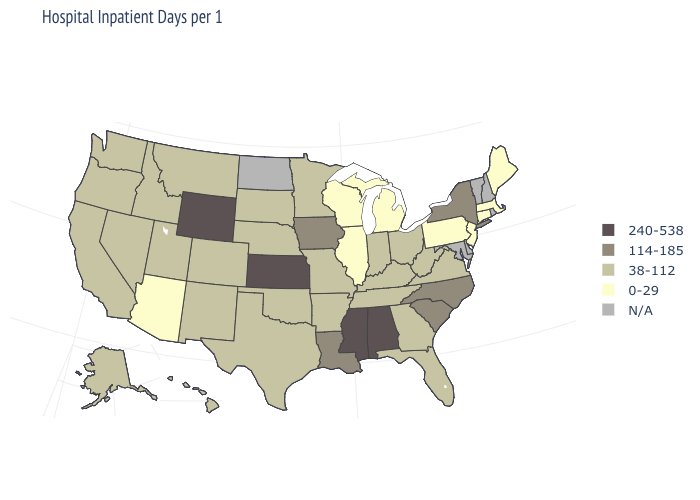What is the value of New Mexico?
Be succinct. 38-112. Name the states that have a value in the range N/A?
Answer briefly. Delaware, Maryland, New Hampshire, North Dakota, Rhode Island, Vermont. Name the states that have a value in the range 240-538?
Keep it brief. Alabama, Kansas, Mississippi, Wyoming. Name the states that have a value in the range N/A?
Write a very short answer. Delaware, Maryland, New Hampshire, North Dakota, Rhode Island, Vermont. Name the states that have a value in the range 240-538?
Quick response, please. Alabama, Kansas, Mississippi, Wyoming. Which states hav the highest value in the West?
Short answer required. Wyoming. Which states have the lowest value in the MidWest?
Short answer required. Illinois, Michigan, Wisconsin. Among the states that border Ohio , does West Virginia have the highest value?
Answer briefly. Yes. What is the lowest value in the USA?
Answer briefly. 0-29. What is the value of Missouri?
Give a very brief answer. 38-112. What is the value of Idaho?
Short answer required. 38-112. Which states have the lowest value in the USA?
Short answer required. Arizona, Connecticut, Illinois, Maine, Massachusetts, Michigan, New Jersey, Pennsylvania, Wisconsin. Name the states that have a value in the range 240-538?
Concise answer only. Alabama, Kansas, Mississippi, Wyoming. What is the highest value in states that border North Carolina?
Answer briefly. 114-185. 